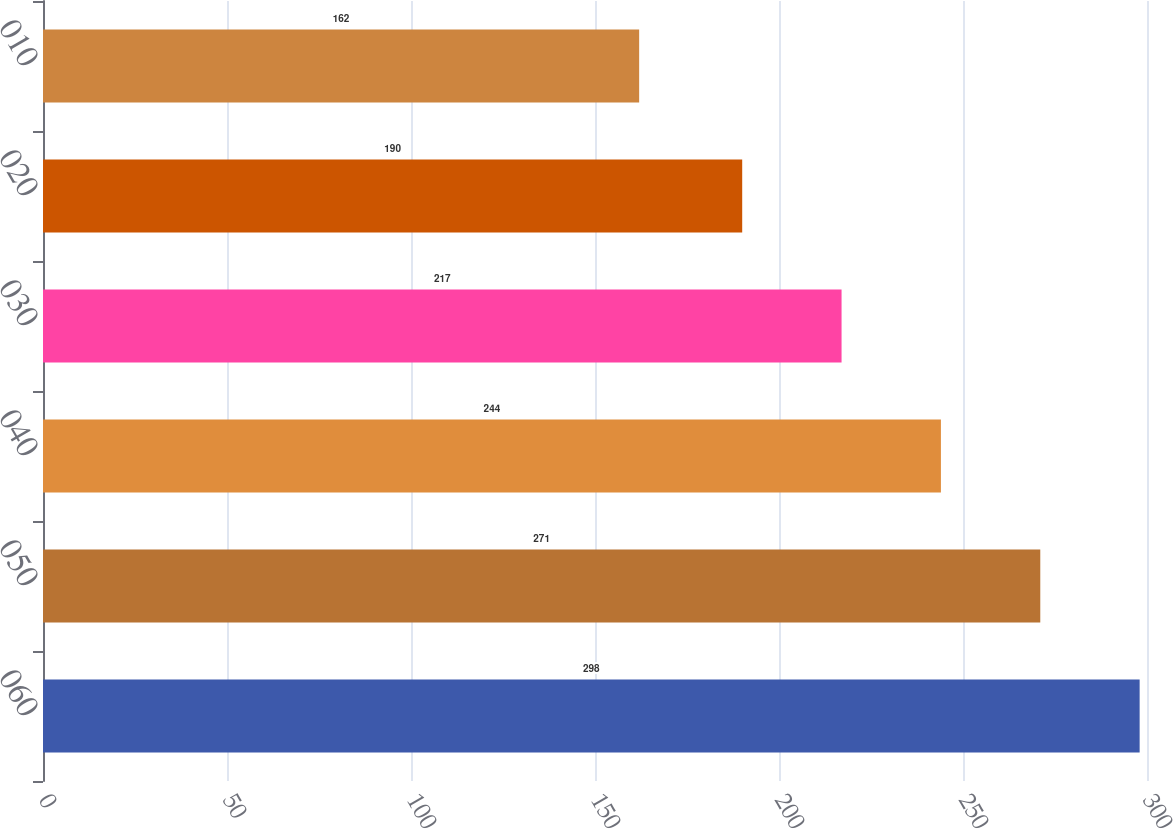Convert chart. <chart><loc_0><loc_0><loc_500><loc_500><bar_chart><fcel>060<fcel>050<fcel>040<fcel>030<fcel>020<fcel>010<nl><fcel>298<fcel>271<fcel>244<fcel>217<fcel>190<fcel>162<nl></chart> 